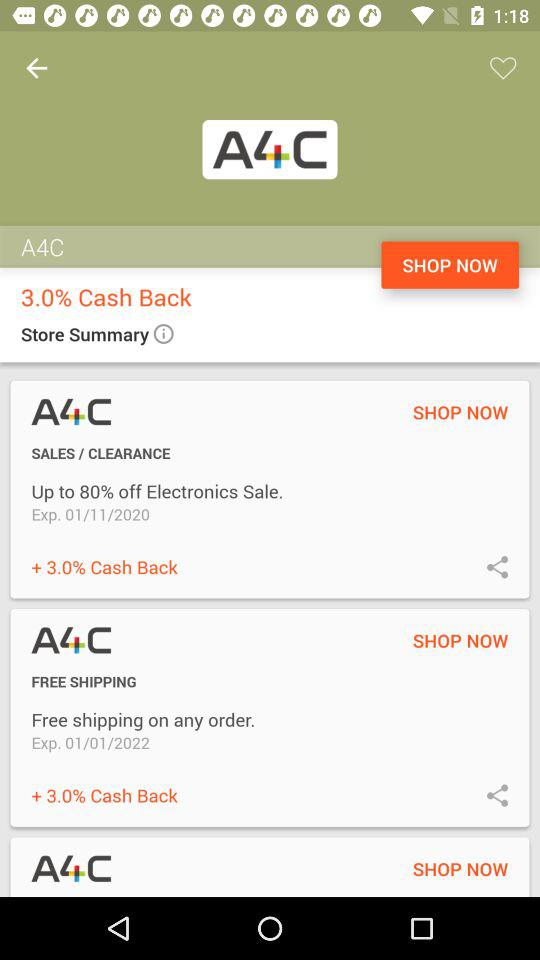What is the cash back offer? The cash back offer is 3.0%. 